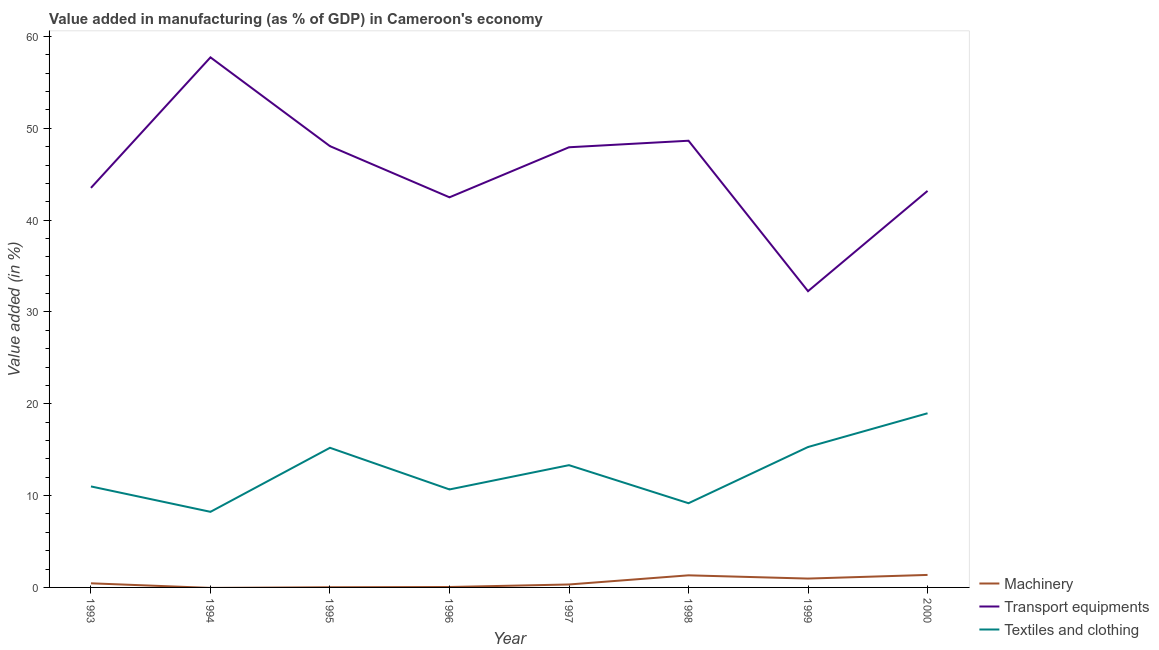How many different coloured lines are there?
Make the answer very short. 3. Does the line corresponding to value added in manufacturing textile and clothing intersect with the line corresponding to value added in manufacturing transport equipments?
Your response must be concise. No. Is the number of lines equal to the number of legend labels?
Make the answer very short. No. What is the value added in manufacturing transport equipments in 1996?
Your answer should be very brief. 42.48. Across all years, what is the maximum value added in manufacturing transport equipments?
Provide a short and direct response. 57.72. Across all years, what is the minimum value added in manufacturing transport equipments?
Your response must be concise. 32.26. What is the total value added in manufacturing textile and clothing in the graph?
Ensure brevity in your answer.  101.85. What is the difference between the value added in manufacturing machinery in 1998 and that in 1999?
Your response must be concise. 0.35. What is the difference between the value added in manufacturing transport equipments in 1995 and the value added in manufacturing machinery in 2000?
Provide a short and direct response. 46.69. What is the average value added in manufacturing textile and clothing per year?
Your answer should be compact. 12.73. In the year 1999, what is the difference between the value added in manufacturing transport equipments and value added in manufacturing textile and clothing?
Offer a very short reply. 16.97. What is the ratio of the value added in manufacturing machinery in 1998 to that in 2000?
Provide a short and direct response. 0.97. What is the difference between the highest and the second highest value added in manufacturing textile and clothing?
Keep it short and to the point. 3.67. What is the difference between the highest and the lowest value added in manufacturing transport equipments?
Provide a succinct answer. 25.46. In how many years, is the value added in manufacturing machinery greater than the average value added in manufacturing machinery taken over all years?
Ensure brevity in your answer.  3. Is it the case that in every year, the sum of the value added in manufacturing machinery and value added in manufacturing transport equipments is greater than the value added in manufacturing textile and clothing?
Your answer should be compact. Yes. Does the value added in manufacturing transport equipments monotonically increase over the years?
Ensure brevity in your answer.  No. What is the difference between two consecutive major ticks on the Y-axis?
Keep it short and to the point. 10. Does the graph contain any zero values?
Give a very brief answer. Yes. Does the graph contain grids?
Ensure brevity in your answer.  No. Where does the legend appear in the graph?
Offer a very short reply. Bottom right. What is the title of the graph?
Keep it short and to the point. Value added in manufacturing (as % of GDP) in Cameroon's economy. Does "Tertiary" appear as one of the legend labels in the graph?
Ensure brevity in your answer.  No. What is the label or title of the Y-axis?
Provide a succinct answer. Value added (in %). What is the Value added (in %) of Machinery in 1993?
Provide a succinct answer. 0.45. What is the Value added (in %) of Transport equipments in 1993?
Provide a short and direct response. 43.51. What is the Value added (in %) of Textiles and clothing in 1993?
Your answer should be compact. 11. What is the Value added (in %) of Machinery in 1994?
Offer a terse response. 0. What is the Value added (in %) in Transport equipments in 1994?
Your answer should be compact. 57.72. What is the Value added (in %) of Textiles and clothing in 1994?
Give a very brief answer. 8.23. What is the Value added (in %) of Machinery in 1995?
Offer a terse response. 0.02. What is the Value added (in %) in Transport equipments in 1995?
Make the answer very short. 48.05. What is the Value added (in %) in Textiles and clothing in 1995?
Offer a very short reply. 15.21. What is the Value added (in %) of Machinery in 1996?
Your answer should be compact. 0.05. What is the Value added (in %) in Transport equipments in 1996?
Keep it short and to the point. 42.48. What is the Value added (in %) in Textiles and clothing in 1996?
Provide a succinct answer. 10.67. What is the Value added (in %) of Machinery in 1997?
Ensure brevity in your answer.  0.32. What is the Value added (in %) in Transport equipments in 1997?
Offer a terse response. 47.93. What is the Value added (in %) in Textiles and clothing in 1997?
Offer a very short reply. 13.31. What is the Value added (in %) of Machinery in 1998?
Provide a succinct answer. 1.32. What is the Value added (in %) in Transport equipments in 1998?
Make the answer very short. 48.65. What is the Value added (in %) of Textiles and clothing in 1998?
Your response must be concise. 9.17. What is the Value added (in %) in Machinery in 1999?
Give a very brief answer. 0.96. What is the Value added (in %) in Transport equipments in 1999?
Keep it short and to the point. 32.26. What is the Value added (in %) of Textiles and clothing in 1999?
Give a very brief answer. 15.29. What is the Value added (in %) in Machinery in 2000?
Offer a terse response. 1.36. What is the Value added (in %) in Transport equipments in 2000?
Keep it short and to the point. 43.18. What is the Value added (in %) of Textiles and clothing in 2000?
Your response must be concise. 18.97. Across all years, what is the maximum Value added (in %) in Machinery?
Your answer should be compact. 1.36. Across all years, what is the maximum Value added (in %) of Transport equipments?
Provide a succinct answer. 57.72. Across all years, what is the maximum Value added (in %) of Textiles and clothing?
Your answer should be very brief. 18.97. Across all years, what is the minimum Value added (in %) in Transport equipments?
Give a very brief answer. 32.26. Across all years, what is the minimum Value added (in %) in Textiles and clothing?
Your response must be concise. 8.23. What is the total Value added (in %) of Machinery in the graph?
Make the answer very short. 4.48. What is the total Value added (in %) of Transport equipments in the graph?
Your answer should be very brief. 363.8. What is the total Value added (in %) of Textiles and clothing in the graph?
Ensure brevity in your answer.  101.85. What is the difference between the Value added (in %) in Transport equipments in 1993 and that in 1994?
Your answer should be compact. -14.21. What is the difference between the Value added (in %) of Textiles and clothing in 1993 and that in 1994?
Provide a short and direct response. 2.77. What is the difference between the Value added (in %) of Machinery in 1993 and that in 1995?
Offer a terse response. 0.43. What is the difference between the Value added (in %) of Transport equipments in 1993 and that in 1995?
Keep it short and to the point. -4.54. What is the difference between the Value added (in %) of Textiles and clothing in 1993 and that in 1995?
Provide a short and direct response. -4.21. What is the difference between the Value added (in %) in Machinery in 1993 and that in 1996?
Offer a terse response. 0.4. What is the difference between the Value added (in %) of Transport equipments in 1993 and that in 1996?
Provide a short and direct response. 1.03. What is the difference between the Value added (in %) in Textiles and clothing in 1993 and that in 1996?
Provide a short and direct response. 0.33. What is the difference between the Value added (in %) of Machinery in 1993 and that in 1997?
Your response must be concise. 0.13. What is the difference between the Value added (in %) in Transport equipments in 1993 and that in 1997?
Give a very brief answer. -4.42. What is the difference between the Value added (in %) of Textiles and clothing in 1993 and that in 1997?
Your answer should be very brief. -2.32. What is the difference between the Value added (in %) in Machinery in 1993 and that in 1998?
Offer a terse response. -0.87. What is the difference between the Value added (in %) in Transport equipments in 1993 and that in 1998?
Keep it short and to the point. -5.13. What is the difference between the Value added (in %) in Textiles and clothing in 1993 and that in 1998?
Your response must be concise. 1.83. What is the difference between the Value added (in %) in Machinery in 1993 and that in 1999?
Make the answer very short. -0.51. What is the difference between the Value added (in %) of Transport equipments in 1993 and that in 1999?
Ensure brevity in your answer.  11.25. What is the difference between the Value added (in %) in Textiles and clothing in 1993 and that in 1999?
Make the answer very short. -4.29. What is the difference between the Value added (in %) in Machinery in 1993 and that in 2000?
Ensure brevity in your answer.  -0.91. What is the difference between the Value added (in %) in Transport equipments in 1993 and that in 2000?
Make the answer very short. 0.33. What is the difference between the Value added (in %) of Textiles and clothing in 1993 and that in 2000?
Your answer should be very brief. -7.97. What is the difference between the Value added (in %) in Transport equipments in 1994 and that in 1995?
Your answer should be compact. 9.67. What is the difference between the Value added (in %) in Textiles and clothing in 1994 and that in 1995?
Provide a succinct answer. -6.97. What is the difference between the Value added (in %) in Transport equipments in 1994 and that in 1996?
Make the answer very short. 15.24. What is the difference between the Value added (in %) in Textiles and clothing in 1994 and that in 1996?
Give a very brief answer. -2.44. What is the difference between the Value added (in %) of Transport equipments in 1994 and that in 1997?
Your answer should be very brief. 9.79. What is the difference between the Value added (in %) in Textiles and clothing in 1994 and that in 1997?
Keep it short and to the point. -5.08. What is the difference between the Value added (in %) of Transport equipments in 1994 and that in 1998?
Keep it short and to the point. 9.08. What is the difference between the Value added (in %) in Textiles and clothing in 1994 and that in 1998?
Your response must be concise. -0.94. What is the difference between the Value added (in %) of Transport equipments in 1994 and that in 1999?
Make the answer very short. 25.46. What is the difference between the Value added (in %) in Textiles and clothing in 1994 and that in 1999?
Keep it short and to the point. -7.06. What is the difference between the Value added (in %) of Transport equipments in 1994 and that in 2000?
Offer a terse response. 14.54. What is the difference between the Value added (in %) in Textiles and clothing in 1994 and that in 2000?
Make the answer very short. -10.73. What is the difference between the Value added (in %) in Machinery in 1995 and that in 1996?
Ensure brevity in your answer.  -0.03. What is the difference between the Value added (in %) in Transport equipments in 1995 and that in 1996?
Ensure brevity in your answer.  5.57. What is the difference between the Value added (in %) of Textiles and clothing in 1995 and that in 1996?
Keep it short and to the point. 4.54. What is the difference between the Value added (in %) of Machinery in 1995 and that in 1997?
Your response must be concise. -0.3. What is the difference between the Value added (in %) of Transport equipments in 1995 and that in 1997?
Your answer should be compact. 0.12. What is the difference between the Value added (in %) of Textiles and clothing in 1995 and that in 1997?
Your answer should be compact. 1.89. What is the difference between the Value added (in %) of Machinery in 1995 and that in 1998?
Ensure brevity in your answer.  -1.3. What is the difference between the Value added (in %) in Transport equipments in 1995 and that in 1998?
Your response must be concise. -0.59. What is the difference between the Value added (in %) of Textiles and clothing in 1995 and that in 1998?
Keep it short and to the point. 6.04. What is the difference between the Value added (in %) in Machinery in 1995 and that in 1999?
Keep it short and to the point. -0.94. What is the difference between the Value added (in %) in Transport equipments in 1995 and that in 1999?
Make the answer very short. 15.79. What is the difference between the Value added (in %) in Textiles and clothing in 1995 and that in 1999?
Make the answer very short. -0.09. What is the difference between the Value added (in %) of Machinery in 1995 and that in 2000?
Provide a short and direct response. -1.34. What is the difference between the Value added (in %) of Transport equipments in 1995 and that in 2000?
Ensure brevity in your answer.  4.87. What is the difference between the Value added (in %) of Textiles and clothing in 1995 and that in 2000?
Provide a short and direct response. -3.76. What is the difference between the Value added (in %) of Machinery in 1996 and that in 1997?
Provide a succinct answer. -0.28. What is the difference between the Value added (in %) in Transport equipments in 1996 and that in 1997?
Your answer should be compact. -5.45. What is the difference between the Value added (in %) in Textiles and clothing in 1996 and that in 1997?
Make the answer very short. -2.64. What is the difference between the Value added (in %) of Machinery in 1996 and that in 1998?
Keep it short and to the point. -1.27. What is the difference between the Value added (in %) of Transport equipments in 1996 and that in 1998?
Your answer should be very brief. -6.16. What is the difference between the Value added (in %) in Textiles and clothing in 1996 and that in 1998?
Offer a terse response. 1.5. What is the difference between the Value added (in %) in Machinery in 1996 and that in 1999?
Offer a terse response. -0.92. What is the difference between the Value added (in %) of Transport equipments in 1996 and that in 1999?
Ensure brevity in your answer.  10.22. What is the difference between the Value added (in %) in Textiles and clothing in 1996 and that in 1999?
Your response must be concise. -4.62. What is the difference between the Value added (in %) in Machinery in 1996 and that in 2000?
Give a very brief answer. -1.32. What is the difference between the Value added (in %) of Transport equipments in 1996 and that in 2000?
Make the answer very short. -0.7. What is the difference between the Value added (in %) in Textiles and clothing in 1996 and that in 2000?
Ensure brevity in your answer.  -8.3. What is the difference between the Value added (in %) in Machinery in 1997 and that in 1998?
Your response must be concise. -1. What is the difference between the Value added (in %) of Transport equipments in 1997 and that in 1998?
Your response must be concise. -0.71. What is the difference between the Value added (in %) of Textiles and clothing in 1997 and that in 1998?
Your response must be concise. 4.14. What is the difference between the Value added (in %) of Machinery in 1997 and that in 1999?
Your response must be concise. -0.64. What is the difference between the Value added (in %) in Transport equipments in 1997 and that in 1999?
Provide a short and direct response. 15.67. What is the difference between the Value added (in %) of Textiles and clothing in 1997 and that in 1999?
Ensure brevity in your answer.  -1.98. What is the difference between the Value added (in %) of Machinery in 1997 and that in 2000?
Ensure brevity in your answer.  -1.04. What is the difference between the Value added (in %) of Transport equipments in 1997 and that in 2000?
Provide a succinct answer. 4.75. What is the difference between the Value added (in %) of Textiles and clothing in 1997 and that in 2000?
Provide a short and direct response. -5.65. What is the difference between the Value added (in %) in Machinery in 1998 and that in 1999?
Ensure brevity in your answer.  0.35. What is the difference between the Value added (in %) in Transport equipments in 1998 and that in 1999?
Your answer should be compact. 16.38. What is the difference between the Value added (in %) in Textiles and clothing in 1998 and that in 1999?
Offer a very short reply. -6.12. What is the difference between the Value added (in %) of Machinery in 1998 and that in 2000?
Provide a short and direct response. -0.04. What is the difference between the Value added (in %) in Transport equipments in 1998 and that in 2000?
Your response must be concise. 5.46. What is the difference between the Value added (in %) of Textiles and clothing in 1998 and that in 2000?
Your response must be concise. -9.8. What is the difference between the Value added (in %) of Machinery in 1999 and that in 2000?
Provide a short and direct response. -0.4. What is the difference between the Value added (in %) in Transport equipments in 1999 and that in 2000?
Offer a terse response. -10.92. What is the difference between the Value added (in %) in Textiles and clothing in 1999 and that in 2000?
Offer a terse response. -3.67. What is the difference between the Value added (in %) in Machinery in 1993 and the Value added (in %) in Transport equipments in 1994?
Give a very brief answer. -57.28. What is the difference between the Value added (in %) of Machinery in 1993 and the Value added (in %) of Textiles and clothing in 1994?
Give a very brief answer. -7.78. What is the difference between the Value added (in %) in Transport equipments in 1993 and the Value added (in %) in Textiles and clothing in 1994?
Provide a succinct answer. 35.28. What is the difference between the Value added (in %) in Machinery in 1993 and the Value added (in %) in Transport equipments in 1995?
Your answer should be compact. -47.61. What is the difference between the Value added (in %) of Machinery in 1993 and the Value added (in %) of Textiles and clothing in 1995?
Keep it short and to the point. -14.76. What is the difference between the Value added (in %) of Transport equipments in 1993 and the Value added (in %) of Textiles and clothing in 1995?
Make the answer very short. 28.3. What is the difference between the Value added (in %) of Machinery in 1993 and the Value added (in %) of Transport equipments in 1996?
Provide a succinct answer. -42.03. What is the difference between the Value added (in %) in Machinery in 1993 and the Value added (in %) in Textiles and clothing in 1996?
Keep it short and to the point. -10.22. What is the difference between the Value added (in %) in Transport equipments in 1993 and the Value added (in %) in Textiles and clothing in 1996?
Your response must be concise. 32.84. What is the difference between the Value added (in %) of Machinery in 1993 and the Value added (in %) of Transport equipments in 1997?
Provide a short and direct response. -47.48. What is the difference between the Value added (in %) in Machinery in 1993 and the Value added (in %) in Textiles and clothing in 1997?
Make the answer very short. -12.87. What is the difference between the Value added (in %) of Transport equipments in 1993 and the Value added (in %) of Textiles and clothing in 1997?
Provide a succinct answer. 30.2. What is the difference between the Value added (in %) in Machinery in 1993 and the Value added (in %) in Transport equipments in 1998?
Offer a very short reply. -48.2. What is the difference between the Value added (in %) of Machinery in 1993 and the Value added (in %) of Textiles and clothing in 1998?
Ensure brevity in your answer.  -8.72. What is the difference between the Value added (in %) of Transport equipments in 1993 and the Value added (in %) of Textiles and clothing in 1998?
Offer a very short reply. 34.34. What is the difference between the Value added (in %) in Machinery in 1993 and the Value added (in %) in Transport equipments in 1999?
Make the answer very short. -31.81. What is the difference between the Value added (in %) of Machinery in 1993 and the Value added (in %) of Textiles and clothing in 1999?
Provide a succinct answer. -14.84. What is the difference between the Value added (in %) in Transport equipments in 1993 and the Value added (in %) in Textiles and clothing in 1999?
Offer a terse response. 28.22. What is the difference between the Value added (in %) of Machinery in 1993 and the Value added (in %) of Transport equipments in 2000?
Provide a succinct answer. -42.73. What is the difference between the Value added (in %) in Machinery in 1993 and the Value added (in %) in Textiles and clothing in 2000?
Your answer should be compact. -18.52. What is the difference between the Value added (in %) of Transport equipments in 1993 and the Value added (in %) of Textiles and clothing in 2000?
Keep it short and to the point. 24.55. What is the difference between the Value added (in %) of Transport equipments in 1994 and the Value added (in %) of Textiles and clothing in 1995?
Ensure brevity in your answer.  42.52. What is the difference between the Value added (in %) of Transport equipments in 1994 and the Value added (in %) of Textiles and clothing in 1996?
Provide a succinct answer. 47.05. What is the difference between the Value added (in %) in Transport equipments in 1994 and the Value added (in %) in Textiles and clothing in 1997?
Give a very brief answer. 44.41. What is the difference between the Value added (in %) of Transport equipments in 1994 and the Value added (in %) of Textiles and clothing in 1998?
Offer a very short reply. 48.55. What is the difference between the Value added (in %) of Transport equipments in 1994 and the Value added (in %) of Textiles and clothing in 1999?
Give a very brief answer. 42.43. What is the difference between the Value added (in %) of Transport equipments in 1994 and the Value added (in %) of Textiles and clothing in 2000?
Offer a terse response. 38.76. What is the difference between the Value added (in %) of Machinery in 1995 and the Value added (in %) of Transport equipments in 1996?
Make the answer very short. -42.46. What is the difference between the Value added (in %) in Machinery in 1995 and the Value added (in %) in Textiles and clothing in 1996?
Keep it short and to the point. -10.65. What is the difference between the Value added (in %) in Transport equipments in 1995 and the Value added (in %) in Textiles and clothing in 1996?
Keep it short and to the point. 37.38. What is the difference between the Value added (in %) of Machinery in 1995 and the Value added (in %) of Transport equipments in 1997?
Your response must be concise. -47.91. What is the difference between the Value added (in %) in Machinery in 1995 and the Value added (in %) in Textiles and clothing in 1997?
Ensure brevity in your answer.  -13.3. What is the difference between the Value added (in %) of Transport equipments in 1995 and the Value added (in %) of Textiles and clothing in 1997?
Offer a very short reply. 34.74. What is the difference between the Value added (in %) in Machinery in 1995 and the Value added (in %) in Transport equipments in 1998?
Give a very brief answer. -48.63. What is the difference between the Value added (in %) of Machinery in 1995 and the Value added (in %) of Textiles and clothing in 1998?
Your answer should be compact. -9.15. What is the difference between the Value added (in %) in Transport equipments in 1995 and the Value added (in %) in Textiles and clothing in 1998?
Keep it short and to the point. 38.88. What is the difference between the Value added (in %) in Machinery in 1995 and the Value added (in %) in Transport equipments in 1999?
Your answer should be very brief. -32.24. What is the difference between the Value added (in %) of Machinery in 1995 and the Value added (in %) of Textiles and clothing in 1999?
Offer a terse response. -15.27. What is the difference between the Value added (in %) of Transport equipments in 1995 and the Value added (in %) of Textiles and clothing in 1999?
Provide a short and direct response. 32.76. What is the difference between the Value added (in %) in Machinery in 1995 and the Value added (in %) in Transport equipments in 2000?
Keep it short and to the point. -43.16. What is the difference between the Value added (in %) in Machinery in 1995 and the Value added (in %) in Textiles and clothing in 2000?
Make the answer very short. -18.95. What is the difference between the Value added (in %) in Transport equipments in 1995 and the Value added (in %) in Textiles and clothing in 2000?
Ensure brevity in your answer.  29.09. What is the difference between the Value added (in %) in Machinery in 1996 and the Value added (in %) in Transport equipments in 1997?
Make the answer very short. -47.89. What is the difference between the Value added (in %) in Machinery in 1996 and the Value added (in %) in Textiles and clothing in 1997?
Give a very brief answer. -13.27. What is the difference between the Value added (in %) of Transport equipments in 1996 and the Value added (in %) of Textiles and clothing in 1997?
Make the answer very short. 29.17. What is the difference between the Value added (in %) of Machinery in 1996 and the Value added (in %) of Transport equipments in 1998?
Your answer should be very brief. -48.6. What is the difference between the Value added (in %) in Machinery in 1996 and the Value added (in %) in Textiles and clothing in 1998?
Offer a very short reply. -9.12. What is the difference between the Value added (in %) in Transport equipments in 1996 and the Value added (in %) in Textiles and clothing in 1998?
Keep it short and to the point. 33.31. What is the difference between the Value added (in %) in Machinery in 1996 and the Value added (in %) in Transport equipments in 1999?
Ensure brevity in your answer.  -32.22. What is the difference between the Value added (in %) of Machinery in 1996 and the Value added (in %) of Textiles and clothing in 1999?
Give a very brief answer. -15.25. What is the difference between the Value added (in %) in Transport equipments in 1996 and the Value added (in %) in Textiles and clothing in 1999?
Offer a very short reply. 27.19. What is the difference between the Value added (in %) of Machinery in 1996 and the Value added (in %) of Transport equipments in 2000?
Provide a short and direct response. -43.14. What is the difference between the Value added (in %) in Machinery in 1996 and the Value added (in %) in Textiles and clothing in 2000?
Your answer should be very brief. -18.92. What is the difference between the Value added (in %) in Transport equipments in 1996 and the Value added (in %) in Textiles and clothing in 2000?
Offer a terse response. 23.52. What is the difference between the Value added (in %) of Machinery in 1997 and the Value added (in %) of Transport equipments in 1998?
Make the answer very short. -48.32. What is the difference between the Value added (in %) in Machinery in 1997 and the Value added (in %) in Textiles and clothing in 1998?
Ensure brevity in your answer.  -8.85. What is the difference between the Value added (in %) in Transport equipments in 1997 and the Value added (in %) in Textiles and clothing in 1998?
Your answer should be compact. 38.76. What is the difference between the Value added (in %) in Machinery in 1997 and the Value added (in %) in Transport equipments in 1999?
Offer a terse response. -31.94. What is the difference between the Value added (in %) in Machinery in 1997 and the Value added (in %) in Textiles and clothing in 1999?
Provide a short and direct response. -14.97. What is the difference between the Value added (in %) of Transport equipments in 1997 and the Value added (in %) of Textiles and clothing in 1999?
Offer a very short reply. 32.64. What is the difference between the Value added (in %) of Machinery in 1997 and the Value added (in %) of Transport equipments in 2000?
Provide a short and direct response. -42.86. What is the difference between the Value added (in %) of Machinery in 1997 and the Value added (in %) of Textiles and clothing in 2000?
Ensure brevity in your answer.  -18.64. What is the difference between the Value added (in %) of Transport equipments in 1997 and the Value added (in %) of Textiles and clothing in 2000?
Your response must be concise. 28.97. What is the difference between the Value added (in %) of Machinery in 1998 and the Value added (in %) of Transport equipments in 1999?
Ensure brevity in your answer.  -30.94. What is the difference between the Value added (in %) in Machinery in 1998 and the Value added (in %) in Textiles and clothing in 1999?
Offer a terse response. -13.97. What is the difference between the Value added (in %) in Transport equipments in 1998 and the Value added (in %) in Textiles and clothing in 1999?
Provide a short and direct response. 33.35. What is the difference between the Value added (in %) of Machinery in 1998 and the Value added (in %) of Transport equipments in 2000?
Give a very brief answer. -41.86. What is the difference between the Value added (in %) of Machinery in 1998 and the Value added (in %) of Textiles and clothing in 2000?
Ensure brevity in your answer.  -17.65. What is the difference between the Value added (in %) in Transport equipments in 1998 and the Value added (in %) in Textiles and clothing in 2000?
Give a very brief answer. 29.68. What is the difference between the Value added (in %) of Machinery in 1999 and the Value added (in %) of Transport equipments in 2000?
Give a very brief answer. -42.22. What is the difference between the Value added (in %) in Machinery in 1999 and the Value added (in %) in Textiles and clothing in 2000?
Your answer should be very brief. -18. What is the difference between the Value added (in %) in Transport equipments in 1999 and the Value added (in %) in Textiles and clothing in 2000?
Ensure brevity in your answer.  13.3. What is the average Value added (in %) of Machinery per year?
Make the answer very short. 0.56. What is the average Value added (in %) of Transport equipments per year?
Offer a very short reply. 45.47. What is the average Value added (in %) of Textiles and clothing per year?
Provide a short and direct response. 12.73. In the year 1993, what is the difference between the Value added (in %) in Machinery and Value added (in %) in Transport equipments?
Provide a short and direct response. -43.06. In the year 1993, what is the difference between the Value added (in %) in Machinery and Value added (in %) in Textiles and clothing?
Ensure brevity in your answer.  -10.55. In the year 1993, what is the difference between the Value added (in %) of Transport equipments and Value added (in %) of Textiles and clothing?
Your answer should be very brief. 32.51. In the year 1994, what is the difference between the Value added (in %) in Transport equipments and Value added (in %) in Textiles and clothing?
Provide a succinct answer. 49.49. In the year 1995, what is the difference between the Value added (in %) of Machinery and Value added (in %) of Transport equipments?
Keep it short and to the point. -48.04. In the year 1995, what is the difference between the Value added (in %) of Machinery and Value added (in %) of Textiles and clothing?
Make the answer very short. -15.19. In the year 1995, what is the difference between the Value added (in %) in Transport equipments and Value added (in %) in Textiles and clothing?
Your answer should be very brief. 32.85. In the year 1996, what is the difference between the Value added (in %) in Machinery and Value added (in %) in Transport equipments?
Offer a very short reply. -42.44. In the year 1996, what is the difference between the Value added (in %) in Machinery and Value added (in %) in Textiles and clothing?
Give a very brief answer. -10.62. In the year 1996, what is the difference between the Value added (in %) in Transport equipments and Value added (in %) in Textiles and clothing?
Give a very brief answer. 31.81. In the year 1997, what is the difference between the Value added (in %) in Machinery and Value added (in %) in Transport equipments?
Provide a succinct answer. -47.61. In the year 1997, what is the difference between the Value added (in %) in Machinery and Value added (in %) in Textiles and clothing?
Your answer should be compact. -12.99. In the year 1997, what is the difference between the Value added (in %) of Transport equipments and Value added (in %) of Textiles and clothing?
Provide a succinct answer. 34.62. In the year 1998, what is the difference between the Value added (in %) in Machinery and Value added (in %) in Transport equipments?
Offer a very short reply. -47.33. In the year 1998, what is the difference between the Value added (in %) in Machinery and Value added (in %) in Textiles and clothing?
Provide a succinct answer. -7.85. In the year 1998, what is the difference between the Value added (in %) of Transport equipments and Value added (in %) of Textiles and clothing?
Provide a succinct answer. 39.48. In the year 1999, what is the difference between the Value added (in %) of Machinery and Value added (in %) of Transport equipments?
Your answer should be compact. -31.3. In the year 1999, what is the difference between the Value added (in %) of Machinery and Value added (in %) of Textiles and clothing?
Ensure brevity in your answer.  -14.33. In the year 1999, what is the difference between the Value added (in %) of Transport equipments and Value added (in %) of Textiles and clothing?
Offer a terse response. 16.97. In the year 2000, what is the difference between the Value added (in %) of Machinery and Value added (in %) of Transport equipments?
Give a very brief answer. -41.82. In the year 2000, what is the difference between the Value added (in %) in Machinery and Value added (in %) in Textiles and clothing?
Keep it short and to the point. -17.6. In the year 2000, what is the difference between the Value added (in %) in Transport equipments and Value added (in %) in Textiles and clothing?
Your answer should be compact. 24.22. What is the ratio of the Value added (in %) in Transport equipments in 1993 to that in 1994?
Ensure brevity in your answer.  0.75. What is the ratio of the Value added (in %) in Textiles and clothing in 1993 to that in 1994?
Offer a very short reply. 1.34. What is the ratio of the Value added (in %) of Machinery in 1993 to that in 1995?
Your answer should be very brief. 23.74. What is the ratio of the Value added (in %) in Transport equipments in 1993 to that in 1995?
Make the answer very short. 0.91. What is the ratio of the Value added (in %) of Textiles and clothing in 1993 to that in 1995?
Give a very brief answer. 0.72. What is the ratio of the Value added (in %) of Machinery in 1993 to that in 1996?
Ensure brevity in your answer.  9.77. What is the ratio of the Value added (in %) of Transport equipments in 1993 to that in 1996?
Your response must be concise. 1.02. What is the ratio of the Value added (in %) of Textiles and clothing in 1993 to that in 1996?
Your answer should be compact. 1.03. What is the ratio of the Value added (in %) in Machinery in 1993 to that in 1997?
Offer a very short reply. 1.4. What is the ratio of the Value added (in %) of Transport equipments in 1993 to that in 1997?
Your answer should be very brief. 0.91. What is the ratio of the Value added (in %) in Textiles and clothing in 1993 to that in 1997?
Your response must be concise. 0.83. What is the ratio of the Value added (in %) of Machinery in 1993 to that in 1998?
Your answer should be compact. 0.34. What is the ratio of the Value added (in %) in Transport equipments in 1993 to that in 1998?
Keep it short and to the point. 0.89. What is the ratio of the Value added (in %) in Textiles and clothing in 1993 to that in 1998?
Offer a terse response. 1.2. What is the ratio of the Value added (in %) of Machinery in 1993 to that in 1999?
Keep it short and to the point. 0.47. What is the ratio of the Value added (in %) of Transport equipments in 1993 to that in 1999?
Your answer should be very brief. 1.35. What is the ratio of the Value added (in %) in Textiles and clothing in 1993 to that in 1999?
Offer a terse response. 0.72. What is the ratio of the Value added (in %) of Machinery in 1993 to that in 2000?
Offer a terse response. 0.33. What is the ratio of the Value added (in %) in Transport equipments in 1993 to that in 2000?
Your answer should be compact. 1.01. What is the ratio of the Value added (in %) in Textiles and clothing in 1993 to that in 2000?
Keep it short and to the point. 0.58. What is the ratio of the Value added (in %) of Transport equipments in 1994 to that in 1995?
Your answer should be compact. 1.2. What is the ratio of the Value added (in %) of Textiles and clothing in 1994 to that in 1995?
Provide a succinct answer. 0.54. What is the ratio of the Value added (in %) in Transport equipments in 1994 to that in 1996?
Provide a short and direct response. 1.36. What is the ratio of the Value added (in %) in Textiles and clothing in 1994 to that in 1996?
Make the answer very short. 0.77. What is the ratio of the Value added (in %) in Transport equipments in 1994 to that in 1997?
Offer a terse response. 1.2. What is the ratio of the Value added (in %) in Textiles and clothing in 1994 to that in 1997?
Keep it short and to the point. 0.62. What is the ratio of the Value added (in %) of Transport equipments in 1994 to that in 1998?
Your answer should be compact. 1.19. What is the ratio of the Value added (in %) in Textiles and clothing in 1994 to that in 1998?
Your response must be concise. 0.9. What is the ratio of the Value added (in %) in Transport equipments in 1994 to that in 1999?
Keep it short and to the point. 1.79. What is the ratio of the Value added (in %) in Textiles and clothing in 1994 to that in 1999?
Offer a terse response. 0.54. What is the ratio of the Value added (in %) of Transport equipments in 1994 to that in 2000?
Provide a succinct answer. 1.34. What is the ratio of the Value added (in %) in Textiles and clothing in 1994 to that in 2000?
Offer a very short reply. 0.43. What is the ratio of the Value added (in %) of Machinery in 1995 to that in 1996?
Ensure brevity in your answer.  0.41. What is the ratio of the Value added (in %) in Transport equipments in 1995 to that in 1996?
Your answer should be very brief. 1.13. What is the ratio of the Value added (in %) in Textiles and clothing in 1995 to that in 1996?
Make the answer very short. 1.43. What is the ratio of the Value added (in %) in Machinery in 1995 to that in 1997?
Offer a very short reply. 0.06. What is the ratio of the Value added (in %) of Transport equipments in 1995 to that in 1997?
Give a very brief answer. 1. What is the ratio of the Value added (in %) of Textiles and clothing in 1995 to that in 1997?
Offer a very short reply. 1.14. What is the ratio of the Value added (in %) of Machinery in 1995 to that in 1998?
Offer a terse response. 0.01. What is the ratio of the Value added (in %) in Textiles and clothing in 1995 to that in 1998?
Provide a succinct answer. 1.66. What is the ratio of the Value added (in %) of Machinery in 1995 to that in 1999?
Ensure brevity in your answer.  0.02. What is the ratio of the Value added (in %) of Transport equipments in 1995 to that in 1999?
Make the answer very short. 1.49. What is the ratio of the Value added (in %) of Textiles and clothing in 1995 to that in 1999?
Ensure brevity in your answer.  0.99. What is the ratio of the Value added (in %) in Machinery in 1995 to that in 2000?
Provide a succinct answer. 0.01. What is the ratio of the Value added (in %) in Transport equipments in 1995 to that in 2000?
Offer a terse response. 1.11. What is the ratio of the Value added (in %) of Textiles and clothing in 1995 to that in 2000?
Offer a very short reply. 0.8. What is the ratio of the Value added (in %) of Machinery in 1996 to that in 1997?
Provide a short and direct response. 0.14. What is the ratio of the Value added (in %) in Transport equipments in 1996 to that in 1997?
Keep it short and to the point. 0.89. What is the ratio of the Value added (in %) in Textiles and clothing in 1996 to that in 1997?
Ensure brevity in your answer.  0.8. What is the ratio of the Value added (in %) in Machinery in 1996 to that in 1998?
Give a very brief answer. 0.03. What is the ratio of the Value added (in %) of Transport equipments in 1996 to that in 1998?
Offer a very short reply. 0.87. What is the ratio of the Value added (in %) in Textiles and clothing in 1996 to that in 1998?
Provide a short and direct response. 1.16. What is the ratio of the Value added (in %) in Machinery in 1996 to that in 1999?
Ensure brevity in your answer.  0.05. What is the ratio of the Value added (in %) of Transport equipments in 1996 to that in 1999?
Keep it short and to the point. 1.32. What is the ratio of the Value added (in %) in Textiles and clothing in 1996 to that in 1999?
Provide a short and direct response. 0.7. What is the ratio of the Value added (in %) in Machinery in 1996 to that in 2000?
Your response must be concise. 0.03. What is the ratio of the Value added (in %) of Transport equipments in 1996 to that in 2000?
Ensure brevity in your answer.  0.98. What is the ratio of the Value added (in %) in Textiles and clothing in 1996 to that in 2000?
Provide a short and direct response. 0.56. What is the ratio of the Value added (in %) of Machinery in 1997 to that in 1998?
Give a very brief answer. 0.24. What is the ratio of the Value added (in %) of Transport equipments in 1997 to that in 1998?
Your answer should be compact. 0.99. What is the ratio of the Value added (in %) in Textiles and clothing in 1997 to that in 1998?
Ensure brevity in your answer.  1.45. What is the ratio of the Value added (in %) of Machinery in 1997 to that in 1999?
Your answer should be very brief. 0.33. What is the ratio of the Value added (in %) of Transport equipments in 1997 to that in 1999?
Your answer should be very brief. 1.49. What is the ratio of the Value added (in %) of Textiles and clothing in 1997 to that in 1999?
Offer a very short reply. 0.87. What is the ratio of the Value added (in %) of Machinery in 1997 to that in 2000?
Make the answer very short. 0.24. What is the ratio of the Value added (in %) of Transport equipments in 1997 to that in 2000?
Offer a very short reply. 1.11. What is the ratio of the Value added (in %) in Textiles and clothing in 1997 to that in 2000?
Your response must be concise. 0.7. What is the ratio of the Value added (in %) of Machinery in 1998 to that in 1999?
Your answer should be compact. 1.37. What is the ratio of the Value added (in %) of Transport equipments in 1998 to that in 1999?
Give a very brief answer. 1.51. What is the ratio of the Value added (in %) in Textiles and clothing in 1998 to that in 1999?
Provide a short and direct response. 0.6. What is the ratio of the Value added (in %) in Machinery in 1998 to that in 2000?
Your answer should be compact. 0.97. What is the ratio of the Value added (in %) of Transport equipments in 1998 to that in 2000?
Keep it short and to the point. 1.13. What is the ratio of the Value added (in %) in Textiles and clothing in 1998 to that in 2000?
Make the answer very short. 0.48. What is the ratio of the Value added (in %) of Machinery in 1999 to that in 2000?
Keep it short and to the point. 0.71. What is the ratio of the Value added (in %) in Transport equipments in 1999 to that in 2000?
Offer a terse response. 0.75. What is the ratio of the Value added (in %) in Textiles and clothing in 1999 to that in 2000?
Offer a very short reply. 0.81. What is the difference between the highest and the second highest Value added (in %) of Machinery?
Keep it short and to the point. 0.04. What is the difference between the highest and the second highest Value added (in %) of Transport equipments?
Offer a terse response. 9.08. What is the difference between the highest and the second highest Value added (in %) in Textiles and clothing?
Ensure brevity in your answer.  3.67. What is the difference between the highest and the lowest Value added (in %) in Machinery?
Offer a very short reply. 1.36. What is the difference between the highest and the lowest Value added (in %) in Transport equipments?
Your answer should be compact. 25.46. What is the difference between the highest and the lowest Value added (in %) of Textiles and clothing?
Offer a terse response. 10.73. 